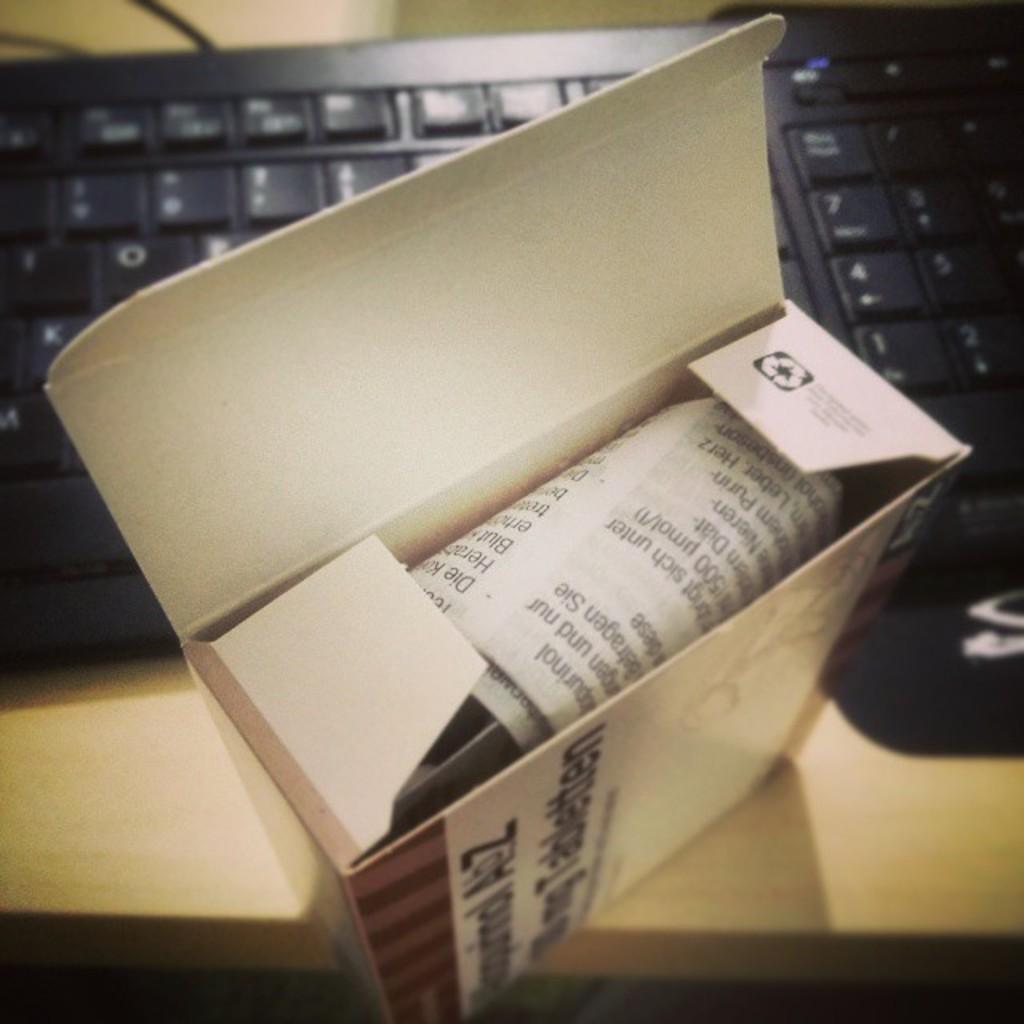What is the last letter on the first row of the box cover?
Your response must be concise. Z. 